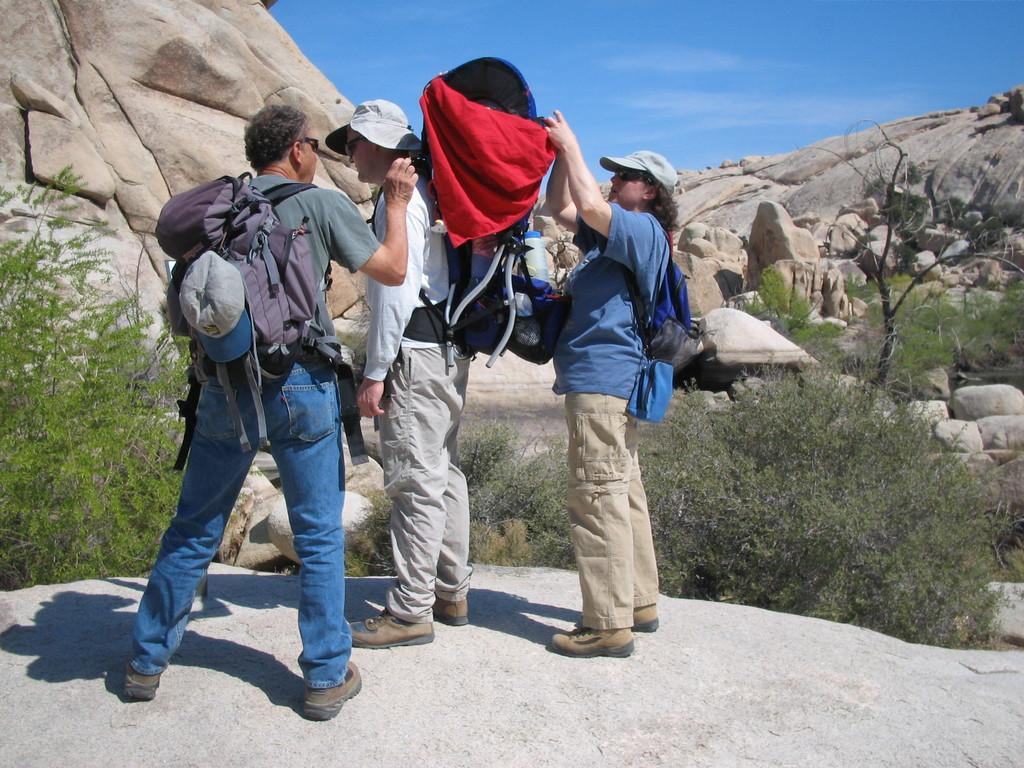How many people are in the image? There are three people standing in the image. What are the people standing on? The people are standing on the ground. What are the people holding in the image? The people are carrying bags. What are the people wearing on their heads? The people are wearing hats. What can be seen in the background of the image? There are trees and plants in the background of the image. What type of harmony is being played by the trees in the background? There is no harmony being played by the trees in the background, as trees do not produce music. 